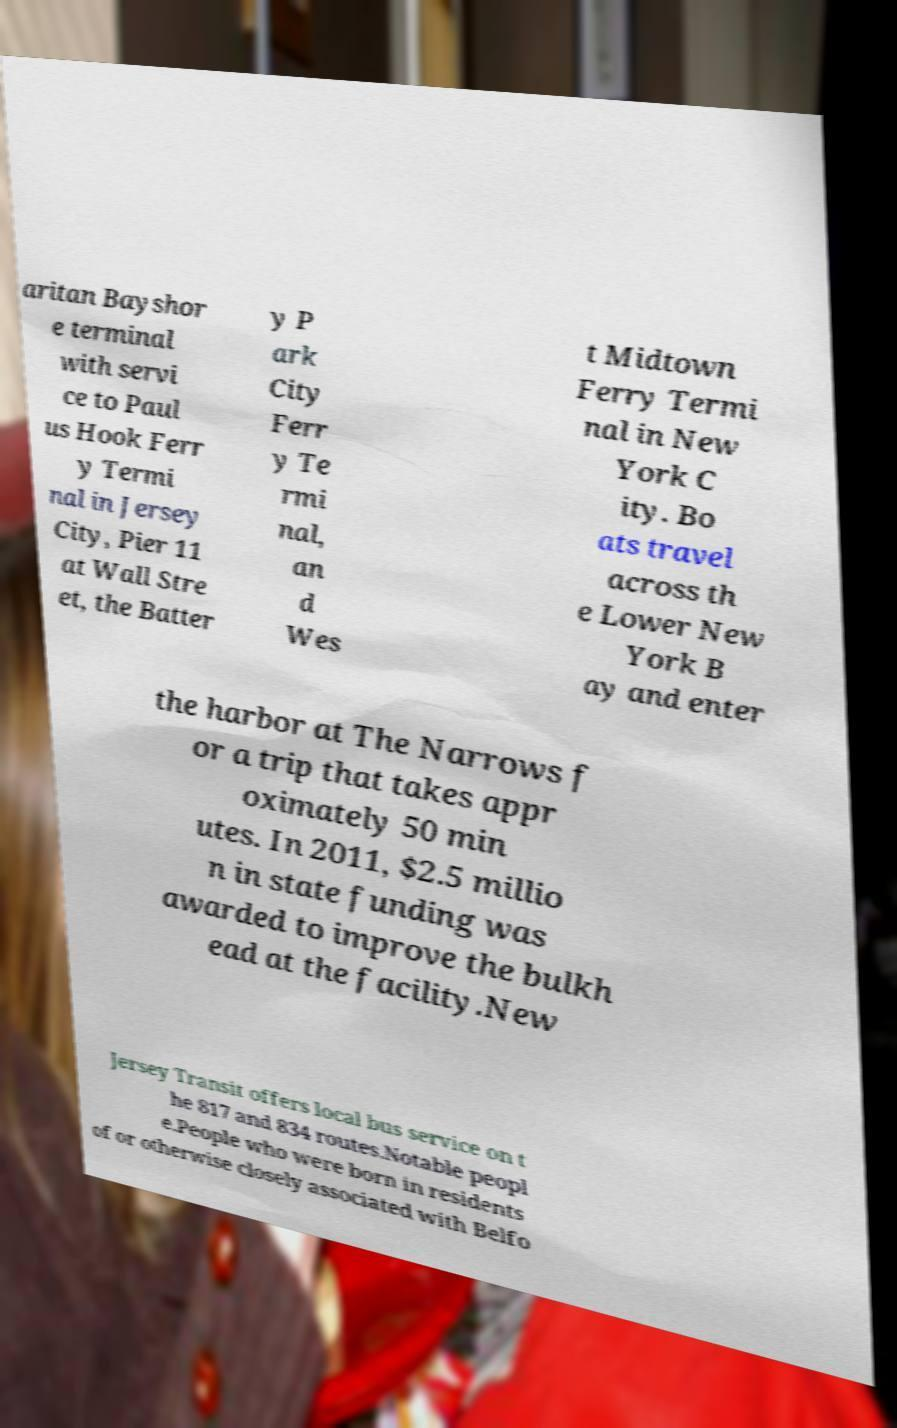There's text embedded in this image that I need extracted. Can you transcribe it verbatim? aritan Bayshor e terminal with servi ce to Paul us Hook Ferr y Termi nal in Jersey City, Pier 11 at Wall Stre et, the Batter y P ark City Ferr y Te rmi nal, an d Wes t Midtown Ferry Termi nal in New York C ity. Bo ats travel across th e Lower New York B ay and enter the harbor at The Narrows f or a trip that takes appr oximately 50 min utes. In 2011, $2.5 millio n in state funding was awarded to improve the bulkh ead at the facility.New Jersey Transit offers local bus service on t he 817 and 834 routes.Notable peopl e.People who were born in residents of or otherwise closely associated with Belfo 